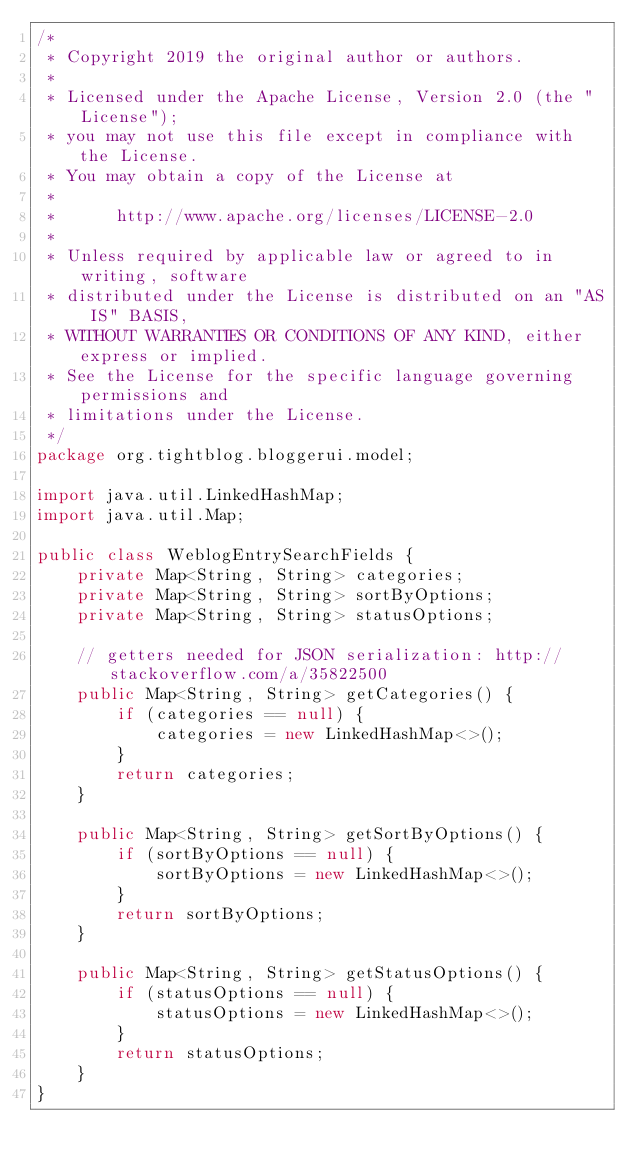Convert code to text. <code><loc_0><loc_0><loc_500><loc_500><_Java_>/*
 * Copyright 2019 the original author or authors.
 *
 * Licensed under the Apache License, Version 2.0 (the "License");
 * you may not use this file except in compliance with the License.
 * You may obtain a copy of the License at
 *
 *      http://www.apache.org/licenses/LICENSE-2.0
 *
 * Unless required by applicable law or agreed to in writing, software
 * distributed under the License is distributed on an "AS IS" BASIS,
 * WITHOUT WARRANTIES OR CONDITIONS OF ANY KIND, either express or implied.
 * See the License for the specific language governing permissions and
 * limitations under the License.
 */
package org.tightblog.bloggerui.model;

import java.util.LinkedHashMap;
import java.util.Map;

public class WeblogEntrySearchFields {
    private Map<String, String> categories;
    private Map<String, String> sortByOptions;
    private Map<String, String> statusOptions;

    // getters needed for JSON serialization: http://stackoverflow.com/a/35822500
    public Map<String, String> getCategories() {
        if (categories == null) {
            categories = new LinkedHashMap<>();
        }
        return categories;
    }

    public Map<String, String> getSortByOptions() {
        if (sortByOptions == null) {
            sortByOptions = new LinkedHashMap<>();
        }
        return sortByOptions;
    }

    public Map<String, String> getStatusOptions() {
        if (statusOptions == null) {
            statusOptions = new LinkedHashMap<>();
        }
        return statusOptions;
    }
}
</code> 